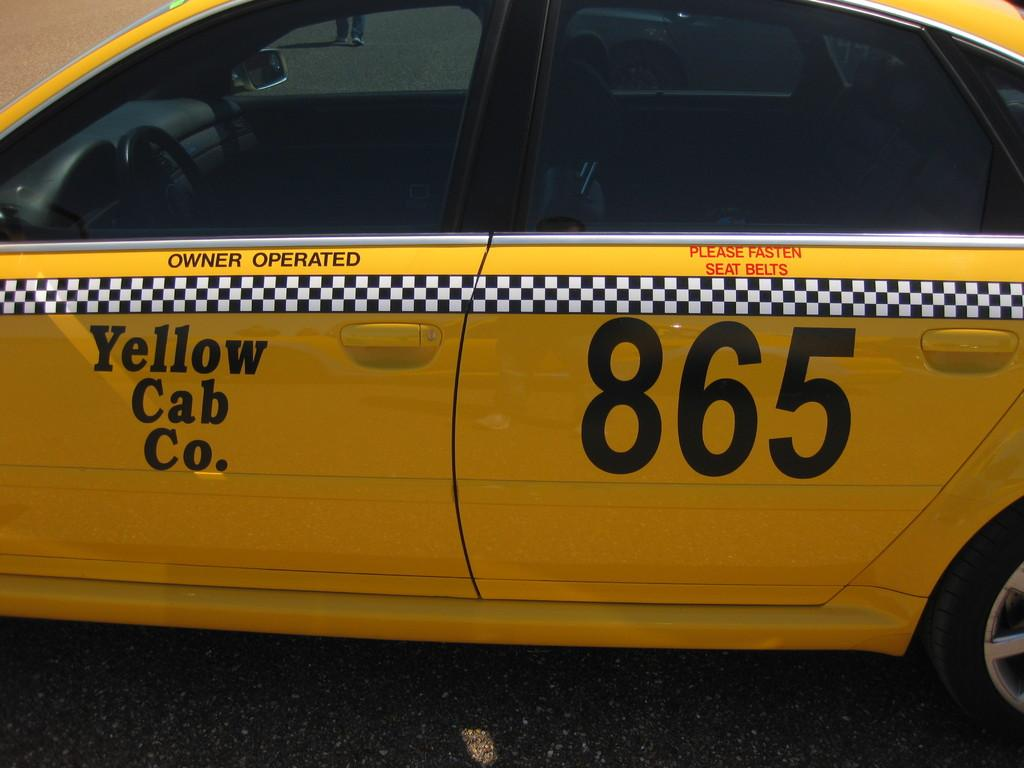<image>
Write a terse but informative summary of the picture. A yellow car that says Yellow Cab Co. has the number 865 on the rear passenger door. 